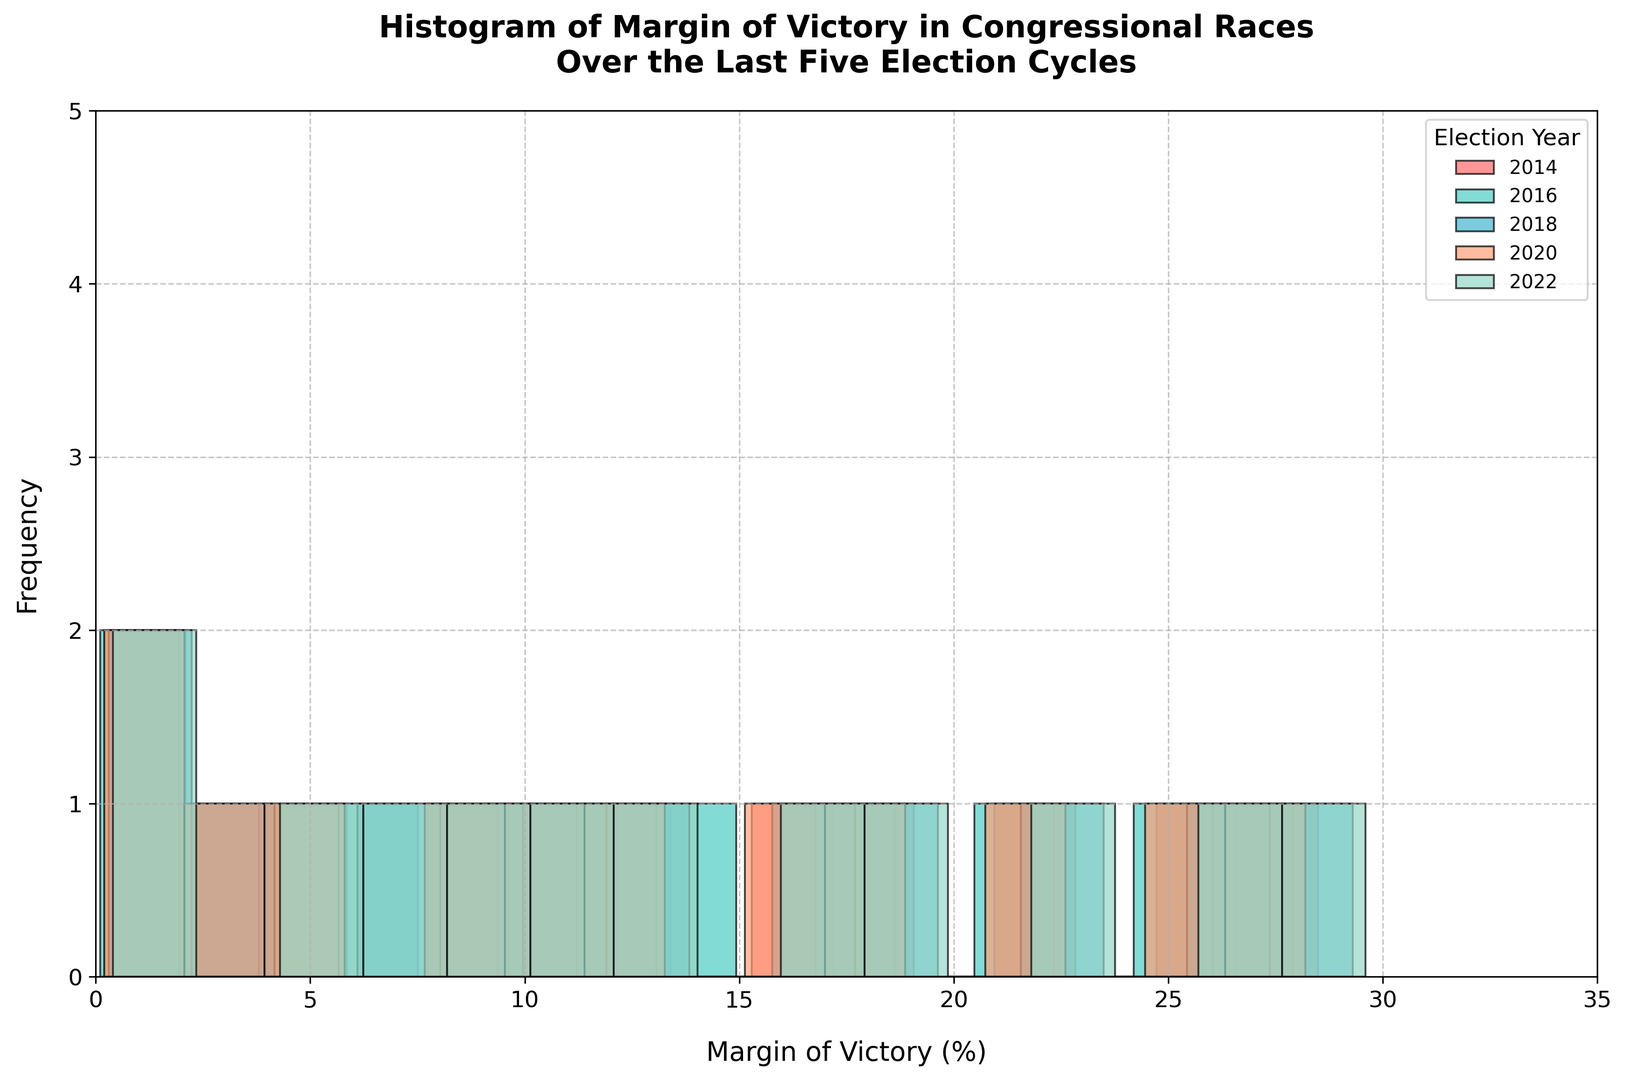What is the highest frequency of margins of victory in the 2016 election cycle? To find the highest frequency, look at the histogram for the 2016 election cycle. Identify the bin with the tallest bar. The highest frequency on this bar represents the most common margin of victory.
Answer: 3 Between the 2018 and 2022 election cycles, which year has a more consistent margin of victory and how can you tell? Consistency can be inferred by examining the variability in the bar heights. For 2018 and 2022, compare the spread and uniformity of the bars in their respective histograms. The year with more bars of similar height likely has a more consistent margin of victory.
Answer: 2022 Which election year had more races decided with a margin of victory between 10% and 15%? Identify the bins corresponding to margins of victory from 10% to 15% in each election year's histogram. Count the heights of the bars in this range and determine which year has a higher cumulative height.
Answer: 2020 How does the range of margins of victory in the 2014 election compare to that in the 2020 election? Determine the range of margins of victory by identifying the smallest and largest margins for both 2014 and 2020 from the histograms. Calculate the difference (range) for each year and compare these values.
Answer: 2014's range is smaller than 2020's Which election year shows the most diverse range of margins of victory and why? Diversity in the range of margins of victory can be deduced from the spread and variation in bin heights across the histogram. The year with the widest spread of bars having significant frequencies represents the most diverse range.
Answer: 2022 In which election year did more races have a margin of victory less than 5%? Look at the bins representing less than 5% margins in the histograms for all election years. Compare the heights of these bars to determine the year with the highest cumulative height for these bins.
Answer: 2016 What is the approximate average margin of victory in the 2018 election year? Visualize the center point of the histogram for the 2018 election year. Estimate the average margin by considering the symmetrical distribution around this central point and the relative heights of the bars.
Answer: Approximately 15% How do the frequencies of races with a margin of victory between 25% and 30% compare across all election years? Identify the bins for margins between 25% and 30% in the histograms for all election years. Compare the heights of these bars to see which years have higher or lower frequencies within this range. Summarize the relative frequencies by rank ordering them from highest to lowest.
Answer: 2016 > 2022 > 2018 > 2020 > 2014 Which election year has the least number of races with a margin of victory greater than 20%? Identify the bins for margins greater than 20% in each election year's histogram. Compare the heights of these bars and summarize which year has the lowest cumulative height for these bins.
Answer: 2020 